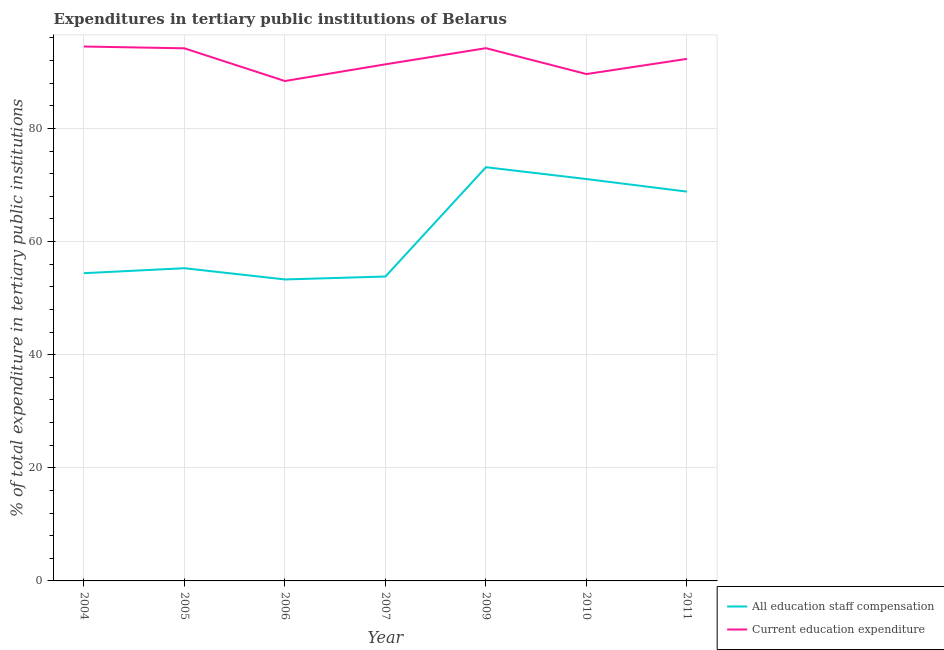Does the line corresponding to expenditure in education intersect with the line corresponding to expenditure in staff compensation?
Keep it short and to the point. No. Is the number of lines equal to the number of legend labels?
Your response must be concise. Yes. What is the expenditure in staff compensation in 2005?
Provide a succinct answer. 55.29. Across all years, what is the maximum expenditure in staff compensation?
Your response must be concise. 73.15. Across all years, what is the minimum expenditure in education?
Provide a short and direct response. 88.39. What is the total expenditure in staff compensation in the graph?
Provide a short and direct response. 429.85. What is the difference between the expenditure in education in 2004 and that in 2007?
Give a very brief answer. 3.15. What is the difference between the expenditure in staff compensation in 2011 and the expenditure in education in 2009?
Offer a very short reply. -25.37. What is the average expenditure in education per year?
Give a very brief answer. 92.07. In the year 2011, what is the difference between the expenditure in staff compensation and expenditure in education?
Provide a short and direct response. -23.47. What is the ratio of the expenditure in education in 2007 to that in 2011?
Your response must be concise. 0.99. Is the expenditure in education in 2009 less than that in 2011?
Ensure brevity in your answer.  No. Is the difference between the expenditure in education in 2004 and 2007 greater than the difference between the expenditure in staff compensation in 2004 and 2007?
Offer a terse response. Yes. What is the difference between the highest and the second highest expenditure in education?
Offer a very short reply. 0.29. What is the difference between the highest and the lowest expenditure in education?
Your answer should be compact. 6.1. Does the expenditure in staff compensation monotonically increase over the years?
Provide a short and direct response. No. Is the expenditure in education strictly less than the expenditure in staff compensation over the years?
Give a very brief answer. No. How many years are there in the graph?
Your answer should be compact. 7. What is the difference between two consecutive major ticks on the Y-axis?
Provide a short and direct response. 20. Are the values on the major ticks of Y-axis written in scientific E-notation?
Make the answer very short. No. Does the graph contain grids?
Offer a terse response. Yes. Where does the legend appear in the graph?
Offer a terse response. Bottom right. How are the legend labels stacked?
Provide a short and direct response. Vertical. What is the title of the graph?
Make the answer very short. Expenditures in tertiary public institutions of Belarus. Does "Urban" appear as one of the legend labels in the graph?
Give a very brief answer. No. What is the label or title of the Y-axis?
Your answer should be very brief. % of total expenditure in tertiary public institutions. What is the % of total expenditure in tertiary public institutions in All education staff compensation in 2004?
Your answer should be very brief. 54.41. What is the % of total expenditure in tertiary public institutions of Current education expenditure in 2004?
Offer a very short reply. 94.49. What is the % of total expenditure in tertiary public institutions in All education staff compensation in 2005?
Your answer should be very brief. 55.29. What is the % of total expenditure in tertiary public institutions in Current education expenditure in 2005?
Ensure brevity in your answer.  94.17. What is the % of total expenditure in tertiary public institutions in All education staff compensation in 2006?
Give a very brief answer. 53.3. What is the % of total expenditure in tertiary public institutions of Current education expenditure in 2006?
Provide a short and direct response. 88.39. What is the % of total expenditure in tertiary public institutions of All education staff compensation in 2007?
Provide a succinct answer. 53.82. What is the % of total expenditure in tertiary public institutions in Current education expenditure in 2007?
Your answer should be very brief. 91.34. What is the % of total expenditure in tertiary public institutions of All education staff compensation in 2009?
Make the answer very short. 73.15. What is the % of total expenditure in tertiary public institutions of Current education expenditure in 2009?
Offer a terse response. 94.19. What is the % of total expenditure in tertiary public institutions in All education staff compensation in 2010?
Offer a terse response. 71.05. What is the % of total expenditure in tertiary public institutions of Current education expenditure in 2010?
Provide a succinct answer. 89.62. What is the % of total expenditure in tertiary public institutions in All education staff compensation in 2011?
Offer a very short reply. 68.83. What is the % of total expenditure in tertiary public institutions of Current education expenditure in 2011?
Keep it short and to the point. 92.3. Across all years, what is the maximum % of total expenditure in tertiary public institutions of All education staff compensation?
Your response must be concise. 73.15. Across all years, what is the maximum % of total expenditure in tertiary public institutions in Current education expenditure?
Your answer should be compact. 94.49. Across all years, what is the minimum % of total expenditure in tertiary public institutions in All education staff compensation?
Ensure brevity in your answer.  53.3. Across all years, what is the minimum % of total expenditure in tertiary public institutions of Current education expenditure?
Ensure brevity in your answer.  88.39. What is the total % of total expenditure in tertiary public institutions in All education staff compensation in the graph?
Offer a terse response. 429.85. What is the total % of total expenditure in tertiary public institutions of Current education expenditure in the graph?
Offer a very short reply. 644.49. What is the difference between the % of total expenditure in tertiary public institutions of All education staff compensation in 2004 and that in 2005?
Give a very brief answer. -0.88. What is the difference between the % of total expenditure in tertiary public institutions of Current education expenditure in 2004 and that in 2005?
Offer a very short reply. 0.32. What is the difference between the % of total expenditure in tertiary public institutions in All education staff compensation in 2004 and that in 2006?
Provide a short and direct response. 1.11. What is the difference between the % of total expenditure in tertiary public institutions in Current education expenditure in 2004 and that in 2006?
Your answer should be compact. 6.1. What is the difference between the % of total expenditure in tertiary public institutions in All education staff compensation in 2004 and that in 2007?
Provide a succinct answer. 0.59. What is the difference between the % of total expenditure in tertiary public institutions in Current education expenditure in 2004 and that in 2007?
Make the answer very short. 3.15. What is the difference between the % of total expenditure in tertiary public institutions of All education staff compensation in 2004 and that in 2009?
Keep it short and to the point. -18.73. What is the difference between the % of total expenditure in tertiary public institutions in Current education expenditure in 2004 and that in 2009?
Give a very brief answer. 0.29. What is the difference between the % of total expenditure in tertiary public institutions in All education staff compensation in 2004 and that in 2010?
Offer a very short reply. -16.64. What is the difference between the % of total expenditure in tertiary public institutions in Current education expenditure in 2004 and that in 2010?
Your response must be concise. 4.87. What is the difference between the % of total expenditure in tertiary public institutions of All education staff compensation in 2004 and that in 2011?
Offer a terse response. -14.42. What is the difference between the % of total expenditure in tertiary public institutions of Current education expenditure in 2004 and that in 2011?
Offer a terse response. 2.18. What is the difference between the % of total expenditure in tertiary public institutions of All education staff compensation in 2005 and that in 2006?
Your response must be concise. 1.99. What is the difference between the % of total expenditure in tertiary public institutions in Current education expenditure in 2005 and that in 2006?
Offer a terse response. 5.78. What is the difference between the % of total expenditure in tertiary public institutions of All education staff compensation in 2005 and that in 2007?
Make the answer very short. 1.47. What is the difference between the % of total expenditure in tertiary public institutions in Current education expenditure in 2005 and that in 2007?
Keep it short and to the point. 2.83. What is the difference between the % of total expenditure in tertiary public institutions of All education staff compensation in 2005 and that in 2009?
Your response must be concise. -17.86. What is the difference between the % of total expenditure in tertiary public institutions of Current education expenditure in 2005 and that in 2009?
Offer a very short reply. -0.03. What is the difference between the % of total expenditure in tertiary public institutions of All education staff compensation in 2005 and that in 2010?
Provide a succinct answer. -15.77. What is the difference between the % of total expenditure in tertiary public institutions in Current education expenditure in 2005 and that in 2010?
Keep it short and to the point. 4.55. What is the difference between the % of total expenditure in tertiary public institutions of All education staff compensation in 2005 and that in 2011?
Provide a succinct answer. -13.54. What is the difference between the % of total expenditure in tertiary public institutions of Current education expenditure in 2005 and that in 2011?
Offer a very short reply. 1.86. What is the difference between the % of total expenditure in tertiary public institutions of All education staff compensation in 2006 and that in 2007?
Make the answer very short. -0.52. What is the difference between the % of total expenditure in tertiary public institutions in Current education expenditure in 2006 and that in 2007?
Ensure brevity in your answer.  -2.95. What is the difference between the % of total expenditure in tertiary public institutions of All education staff compensation in 2006 and that in 2009?
Offer a terse response. -19.84. What is the difference between the % of total expenditure in tertiary public institutions of Current education expenditure in 2006 and that in 2009?
Your answer should be very brief. -5.81. What is the difference between the % of total expenditure in tertiary public institutions in All education staff compensation in 2006 and that in 2010?
Offer a very short reply. -17.75. What is the difference between the % of total expenditure in tertiary public institutions of Current education expenditure in 2006 and that in 2010?
Ensure brevity in your answer.  -1.23. What is the difference between the % of total expenditure in tertiary public institutions of All education staff compensation in 2006 and that in 2011?
Make the answer very short. -15.53. What is the difference between the % of total expenditure in tertiary public institutions of Current education expenditure in 2006 and that in 2011?
Keep it short and to the point. -3.92. What is the difference between the % of total expenditure in tertiary public institutions in All education staff compensation in 2007 and that in 2009?
Your answer should be very brief. -19.32. What is the difference between the % of total expenditure in tertiary public institutions of Current education expenditure in 2007 and that in 2009?
Your answer should be compact. -2.86. What is the difference between the % of total expenditure in tertiary public institutions in All education staff compensation in 2007 and that in 2010?
Provide a succinct answer. -17.23. What is the difference between the % of total expenditure in tertiary public institutions in Current education expenditure in 2007 and that in 2010?
Your answer should be compact. 1.72. What is the difference between the % of total expenditure in tertiary public institutions of All education staff compensation in 2007 and that in 2011?
Provide a succinct answer. -15.01. What is the difference between the % of total expenditure in tertiary public institutions in Current education expenditure in 2007 and that in 2011?
Provide a succinct answer. -0.96. What is the difference between the % of total expenditure in tertiary public institutions of All education staff compensation in 2009 and that in 2010?
Your response must be concise. 2.09. What is the difference between the % of total expenditure in tertiary public institutions in Current education expenditure in 2009 and that in 2010?
Provide a short and direct response. 4.58. What is the difference between the % of total expenditure in tertiary public institutions of All education staff compensation in 2009 and that in 2011?
Provide a succinct answer. 4.32. What is the difference between the % of total expenditure in tertiary public institutions of Current education expenditure in 2009 and that in 2011?
Provide a short and direct response. 1.89. What is the difference between the % of total expenditure in tertiary public institutions in All education staff compensation in 2010 and that in 2011?
Keep it short and to the point. 2.23. What is the difference between the % of total expenditure in tertiary public institutions of Current education expenditure in 2010 and that in 2011?
Your answer should be compact. -2.69. What is the difference between the % of total expenditure in tertiary public institutions of All education staff compensation in 2004 and the % of total expenditure in tertiary public institutions of Current education expenditure in 2005?
Ensure brevity in your answer.  -39.76. What is the difference between the % of total expenditure in tertiary public institutions of All education staff compensation in 2004 and the % of total expenditure in tertiary public institutions of Current education expenditure in 2006?
Your response must be concise. -33.98. What is the difference between the % of total expenditure in tertiary public institutions of All education staff compensation in 2004 and the % of total expenditure in tertiary public institutions of Current education expenditure in 2007?
Ensure brevity in your answer.  -36.93. What is the difference between the % of total expenditure in tertiary public institutions of All education staff compensation in 2004 and the % of total expenditure in tertiary public institutions of Current education expenditure in 2009?
Keep it short and to the point. -39.78. What is the difference between the % of total expenditure in tertiary public institutions of All education staff compensation in 2004 and the % of total expenditure in tertiary public institutions of Current education expenditure in 2010?
Your answer should be very brief. -35.21. What is the difference between the % of total expenditure in tertiary public institutions of All education staff compensation in 2004 and the % of total expenditure in tertiary public institutions of Current education expenditure in 2011?
Provide a succinct answer. -37.89. What is the difference between the % of total expenditure in tertiary public institutions in All education staff compensation in 2005 and the % of total expenditure in tertiary public institutions in Current education expenditure in 2006?
Offer a terse response. -33.1. What is the difference between the % of total expenditure in tertiary public institutions of All education staff compensation in 2005 and the % of total expenditure in tertiary public institutions of Current education expenditure in 2007?
Make the answer very short. -36.05. What is the difference between the % of total expenditure in tertiary public institutions in All education staff compensation in 2005 and the % of total expenditure in tertiary public institutions in Current education expenditure in 2009?
Ensure brevity in your answer.  -38.91. What is the difference between the % of total expenditure in tertiary public institutions in All education staff compensation in 2005 and the % of total expenditure in tertiary public institutions in Current education expenditure in 2010?
Offer a terse response. -34.33. What is the difference between the % of total expenditure in tertiary public institutions of All education staff compensation in 2005 and the % of total expenditure in tertiary public institutions of Current education expenditure in 2011?
Offer a terse response. -37.01. What is the difference between the % of total expenditure in tertiary public institutions in All education staff compensation in 2006 and the % of total expenditure in tertiary public institutions in Current education expenditure in 2007?
Offer a terse response. -38.04. What is the difference between the % of total expenditure in tertiary public institutions of All education staff compensation in 2006 and the % of total expenditure in tertiary public institutions of Current education expenditure in 2009?
Offer a very short reply. -40.89. What is the difference between the % of total expenditure in tertiary public institutions of All education staff compensation in 2006 and the % of total expenditure in tertiary public institutions of Current education expenditure in 2010?
Offer a terse response. -36.31. What is the difference between the % of total expenditure in tertiary public institutions in All education staff compensation in 2006 and the % of total expenditure in tertiary public institutions in Current education expenditure in 2011?
Your response must be concise. -39. What is the difference between the % of total expenditure in tertiary public institutions of All education staff compensation in 2007 and the % of total expenditure in tertiary public institutions of Current education expenditure in 2009?
Ensure brevity in your answer.  -40.37. What is the difference between the % of total expenditure in tertiary public institutions of All education staff compensation in 2007 and the % of total expenditure in tertiary public institutions of Current education expenditure in 2010?
Provide a succinct answer. -35.8. What is the difference between the % of total expenditure in tertiary public institutions in All education staff compensation in 2007 and the % of total expenditure in tertiary public institutions in Current education expenditure in 2011?
Make the answer very short. -38.48. What is the difference between the % of total expenditure in tertiary public institutions in All education staff compensation in 2009 and the % of total expenditure in tertiary public institutions in Current education expenditure in 2010?
Your response must be concise. -16.47. What is the difference between the % of total expenditure in tertiary public institutions in All education staff compensation in 2009 and the % of total expenditure in tertiary public institutions in Current education expenditure in 2011?
Make the answer very short. -19.16. What is the difference between the % of total expenditure in tertiary public institutions of All education staff compensation in 2010 and the % of total expenditure in tertiary public institutions of Current education expenditure in 2011?
Give a very brief answer. -21.25. What is the average % of total expenditure in tertiary public institutions of All education staff compensation per year?
Your response must be concise. 61.41. What is the average % of total expenditure in tertiary public institutions of Current education expenditure per year?
Ensure brevity in your answer.  92.07. In the year 2004, what is the difference between the % of total expenditure in tertiary public institutions in All education staff compensation and % of total expenditure in tertiary public institutions in Current education expenditure?
Provide a succinct answer. -40.07. In the year 2005, what is the difference between the % of total expenditure in tertiary public institutions in All education staff compensation and % of total expenditure in tertiary public institutions in Current education expenditure?
Provide a short and direct response. -38.88. In the year 2006, what is the difference between the % of total expenditure in tertiary public institutions of All education staff compensation and % of total expenditure in tertiary public institutions of Current education expenditure?
Make the answer very short. -35.08. In the year 2007, what is the difference between the % of total expenditure in tertiary public institutions in All education staff compensation and % of total expenditure in tertiary public institutions in Current education expenditure?
Your answer should be compact. -37.52. In the year 2009, what is the difference between the % of total expenditure in tertiary public institutions of All education staff compensation and % of total expenditure in tertiary public institutions of Current education expenditure?
Ensure brevity in your answer.  -21.05. In the year 2010, what is the difference between the % of total expenditure in tertiary public institutions in All education staff compensation and % of total expenditure in tertiary public institutions in Current education expenditure?
Make the answer very short. -18.56. In the year 2011, what is the difference between the % of total expenditure in tertiary public institutions of All education staff compensation and % of total expenditure in tertiary public institutions of Current education expenditure?
Your answer should be compact. -23.47. What is the ratio of the % of total expenditure in tertiary public institutions in All education staff compensation in 2004 to that in 2005?
Provide a succinct answer. 0.98. What is the ratio of the % of total expenditure in tertiary public institutions of Current education expenditure in 2004 to that in 2005?
Provide a succinct answer. 1. What is the ratio of the % of total expenditure in tertiary public institutions of All education staff compensation in 2004 to that in 2006?
Offer a very short reply. 1.02. What is the ratio of the % of total expenditure in tertiary public institutions in Current education expenditure in 2004 to that in 2006?
Give a very brief answer. 1.07. What is the ratio of the % of total expenditure in tertiary public institutions in All education staff compensation in 2004 to that in 2007?
Your answer should be very brief. 1.01. What is the ratio of the % of total expenditure in tertiary public institutions in Current education expenditure in 2004 to that in 2007?
Your answer should be compact. 1.03. What is the ratio of the % of total expenditure in tertiary public institutions of All education staff compensation in 2004 to that in 2009?
Ensure brevity in your answer.  0.74. What is the ratio of the % of total expenditure in tertiary public institutions in All education staff compensation in 2004 to that in 2010?
Provide a succinct answer. 0.77. What is the ratio of the % of total expenditure in tertiary public institutions of Current education expenditure in 2004 to that in 2010?
Provide a short and direct response. 1.05. What is the ratio of the % of total expenditure in tertiary public institutions in All education staff compensation in 2004 to that in 2011?
Offer a very short reply. 0.79. What is the ratio of the % of total expenditure in tertiary public institutions of Current education expenditure in 2004 to that in 2011?
Offer a very short reply. 1.02. What is the ratio of the % of total expenditure in tertiary public institutions of All education staff compensation in 2005 to that in 2006?
Keep it short and to the point. 1.04. What is the ratio of the % of total expenditure in tertiary public institutions of Current education expenditure in 2005 to that in 2006?
Your answer should be very brief. 1.07. What is the ratio of the % of total expenditure in tertiary public institutions in All education staff compensation in 2005 to that in 2007?
Your response must be concise. 1.03. What is the ratio of the % of total expenditure in tertiary public institutions of Current education expenditure in 2005 to that in 2007?
Offer a very short reply. 1.03. What is the ratio of the % of total expenditure in tertiary public institutions in All education staff compensation in 2005 to that in 2009?
Your answer should be compact. 0.76. What is the ratio of the % of total expenditure in tertiary public institutions in All education staff compensation in 2005 to that in 2010?
Offer a very short reply. 0.78. What is the ratio of the % of total expenditure in tertiary public institutions in Current education expenditure in 2005 to that in 2010?
Offer a terse response. 1.05. What is the ratio of the % of total expenditure in tertiary public institutions of All education staff compensation in 2005 to that in 2011?
Keep it short and to the point. 0.8. What is the ratio of the % of total expenditure in tertiary public institutions in Current education expenditure in 2005 to that in 2011?
Provide a short and direct response. 1.02. What is the ratio of the % of total expenditure in tertiary public institutions in All education staff compensation in 2006 to that in 2007?
Your answer should be very brief. 0.99. What is the ratio of the % of total expenditure in tertiary public institutions in Current education expenditure in 2006 to that in 2007?
Ensure brevity in your answer.  0.97. What is the ratio of the % of total expenditure in tertiary public institutions of All education staff compensation in 2006 to that in 2009?
Offer a terse response. 0.73. What is the ratio of the % of total expenditure in tertiary public institutions in Current education expenditure in 2006 to that in 2009?
Give a very brief answer. 0.94. What is the ratio of the % of total expenditure in tertiary public institutions in All education staff compensation in 2006 to that in 2010?
Give a very brief answer. 0.75. What is the ratio of the % of total expenditure in tertiary public institutions of Current education expenditure in 2006 to that in 2010?
Your answer should be very brief. 0.99. What is the ratio of the % of total expenditure in tertiary public institutions in All education staff compensation in 2006 to that in 2011?
Offer a very short reply. 0.77. What is the ratio of the % of total expenditure in tertiary public institutions in Current education expenditure in 2006 to that in 2011?
Your answer should be compact. 0.96. What is the ratio of the % of total expenditure in tertiary public institutions of All education staff compensation in 2007 to that in 2009?
Keep it short and to the point. 0.74. What is the ratio of the % of total expenditure in tertiary public institutions in Current education expenditure in 2007 to that in 2009?
Your answer should be very brief. 0.97. What is the ratio of the % of total expenditure in tertiary public institutions of All education staff compensation in 2007 to that in 2010?
Provide a short and direct response. 0.76. What is the ratio of the % of total expenditure in tertiary public institutions of Current education expenditure in 2007 to that in 2010?
Your answer should be very brief. 1.02. What is the ratio of the % of total expenditure in tertiary public institutions in All education staff compensation in 2007 to that in 2011?
Offer a very short reply. 0.78. What is the ratio of the % of total expenditure in tertiary public institutions of Current education expenditure in 2007 to that in 2011?
Your answer should be very brief. 0.99. What is the ratio of the % of total expenditure in tertiary public institutions in All education staff compensation in 2009 to that in 2010?
Your response must be concise. 1.03. What is the ratio of the % of total expenditure in tertiary public institutions of Current education expenditure in 2009 to that in 2010?
Your answer should be very brief. 1.05. What is the ratio of the % of total expenditure in tertiary public institutions of All education staff compensation in 2009 to that in 2011?
Keep it short and to the point. 1.06. What is the ratio of the % of total expenditure in tertiary public institutions in Current education expenditure in 2009 to that in 2011?
Ensure brevity in your answer.  1.02. What is the ratio of the % of total expenditure in tertiary public institutions in All education staff compensation in 2010 to that in 2011?
Offer a terse response. 1.03. What is the ratio of the % of total expenditure in tertiary public institutions of Current education expenditure in 2010 to that in 2011?
Give a very brief answer. 0.97. What is the difference between the highest and the second highest % of total expenditure in tertiary public institutions in All education staff compensation?
Make the answer very short. 2.09. What is the difference between the highest and the second highest % of total expenditure in tertiary public institutions in Current education expenditure?
Provide a short and direct response. 0.29. What is the difference between the highest and the lowest % of total expenditure in tertiary public institutions in All education staff compensation?
Offer a terse response. 19.84. What is the difference between the highest and the lowest % of total expenditure in tertiary public institutions of Current education expenditure?
Give a very brief answer. 6.1. 